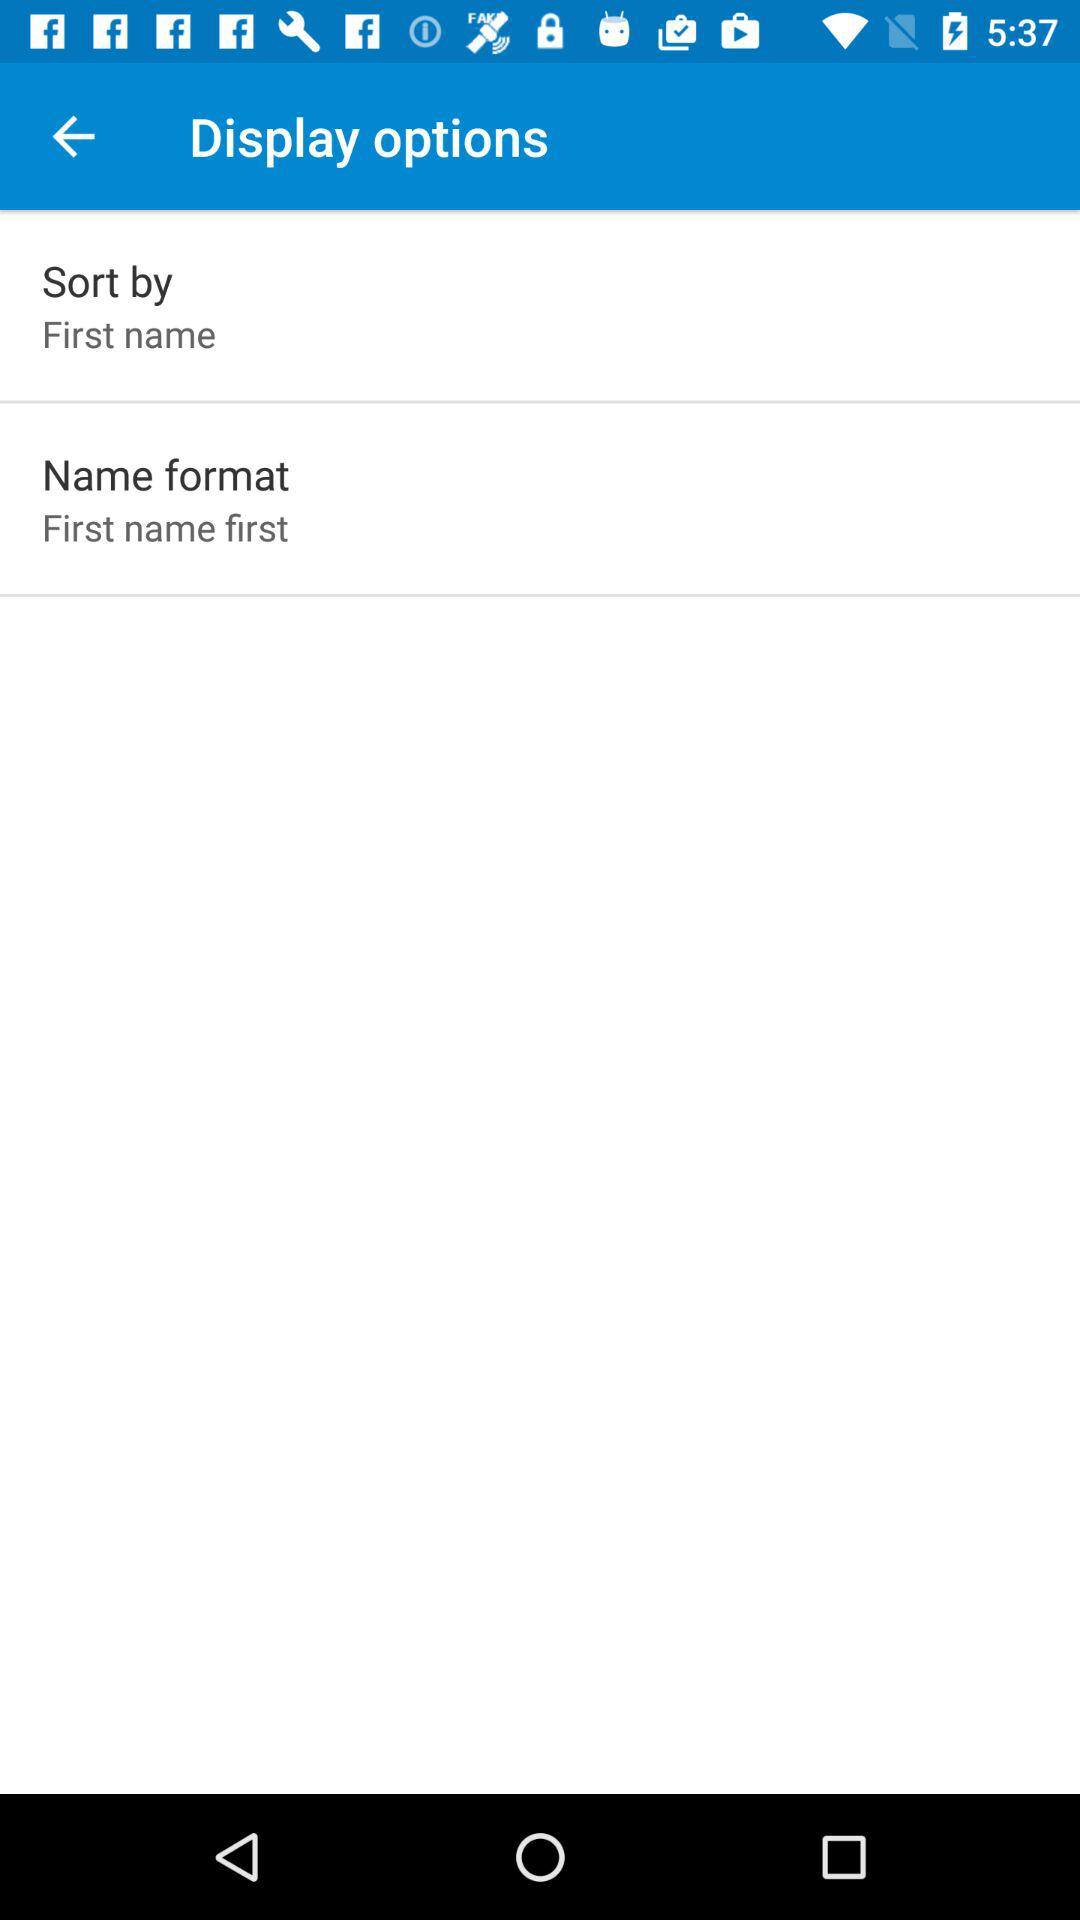What is the selected "Sort by" option in the "Display options"? The selected "Sort by" option is "First name". 